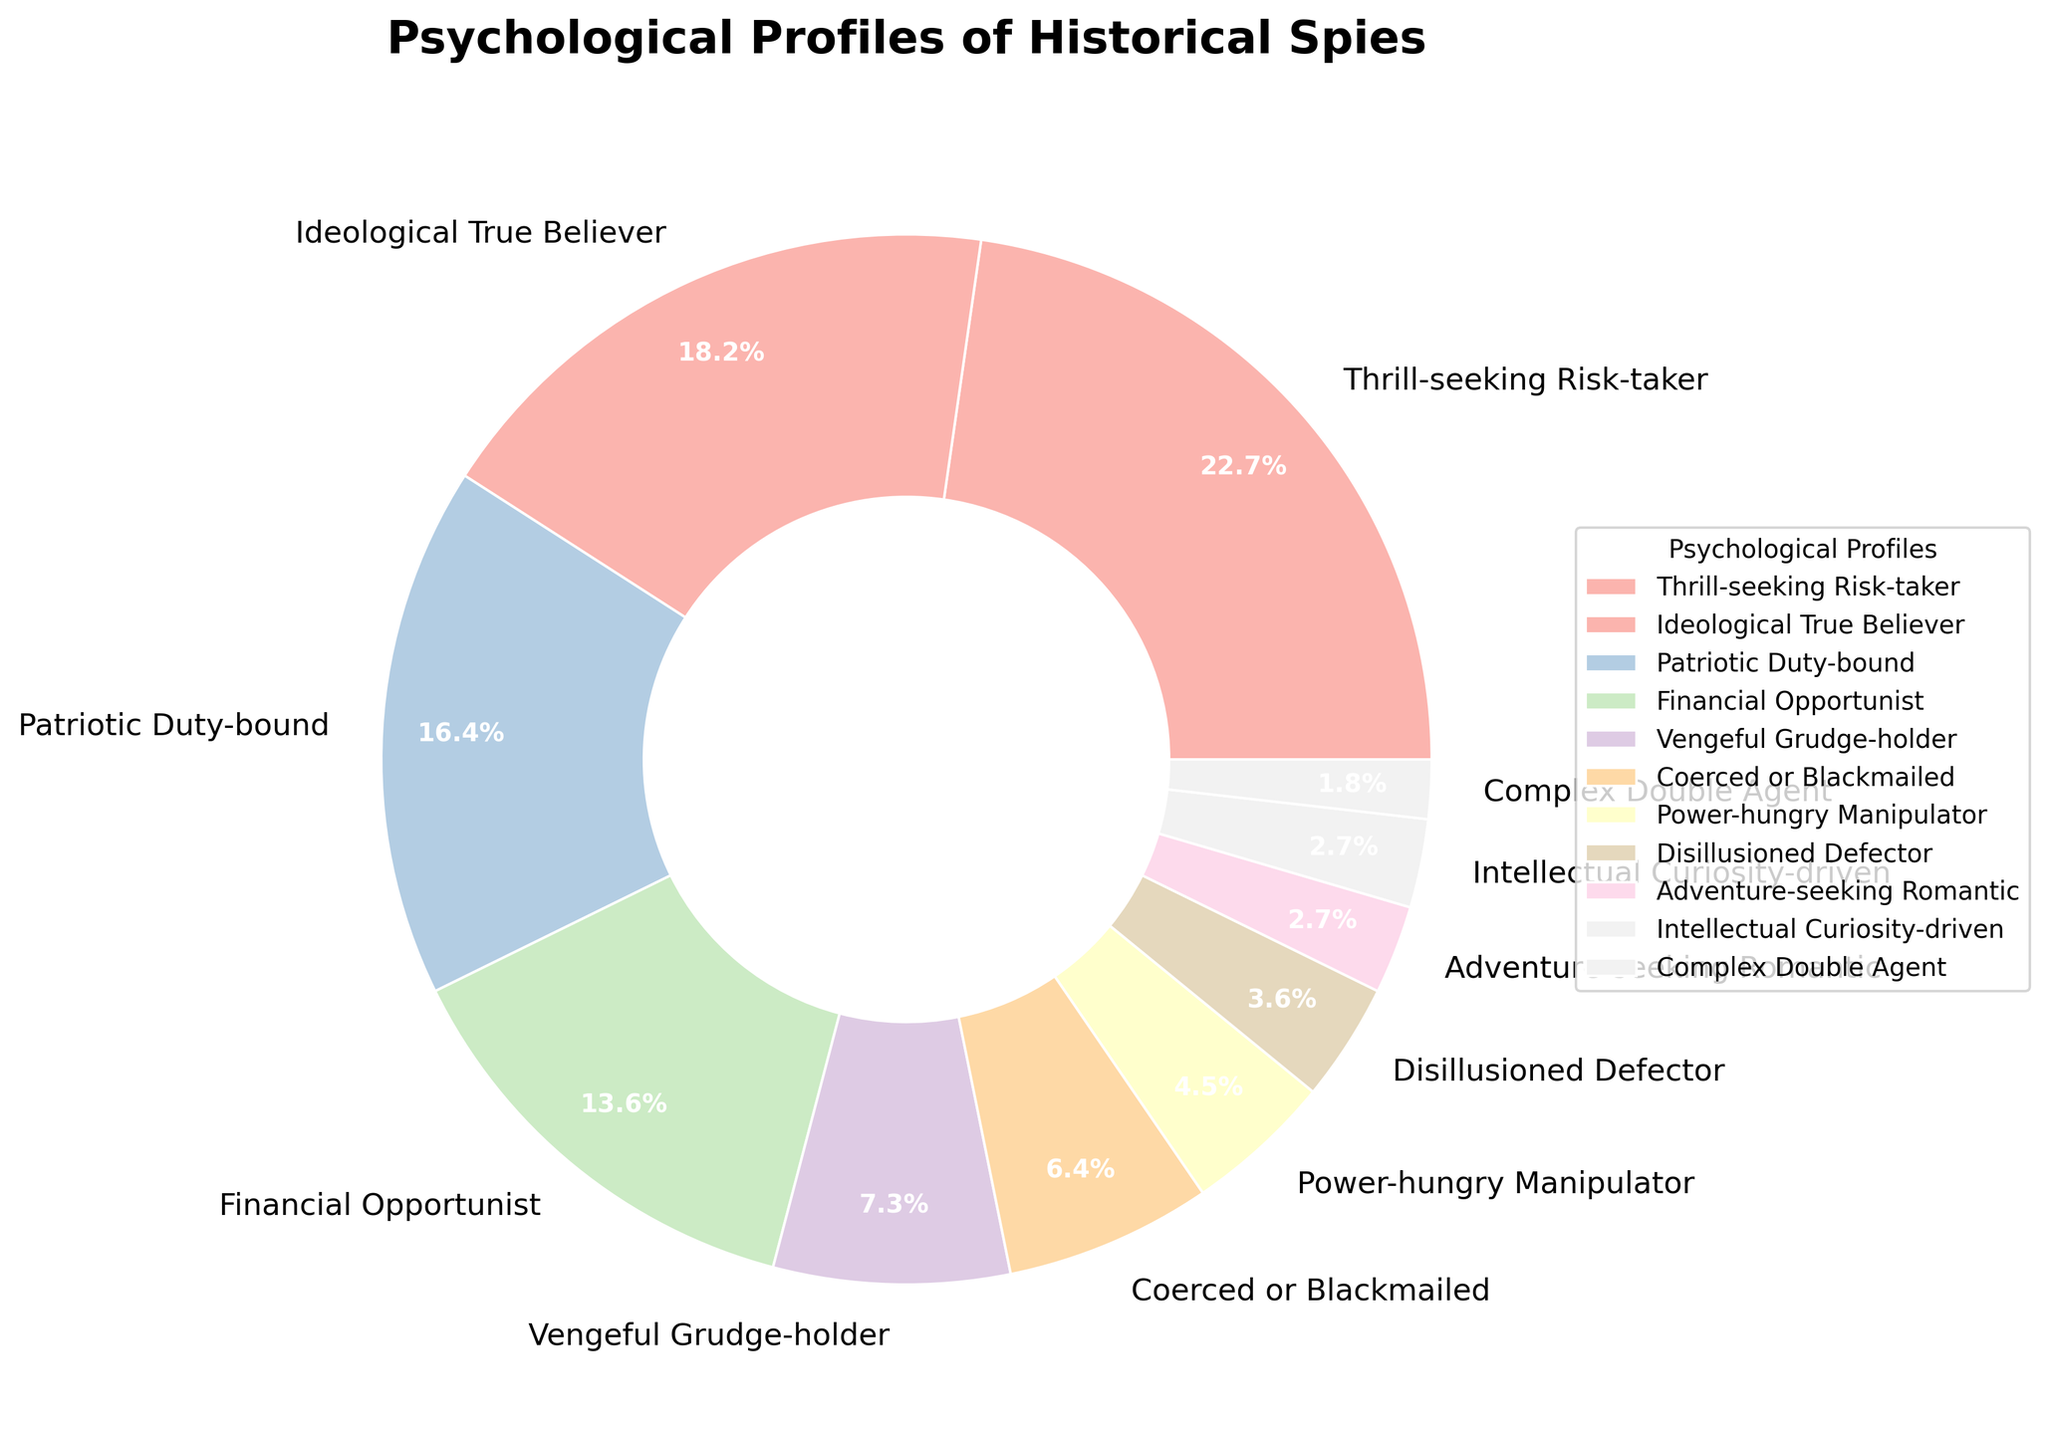Which psychological profile has the highest percentage among historical spies? Refer to the pie chart to identify the segment with the largest portion. The "Thrill-seeking Risk-taker" profile has the highest percentage at 25%.
Answer: Thrill-seeking Risk-taker What is the combined percentage of spies with profiles categorized as "Patriotic Duty-bound” and "Ideological True Believer"? Add the percentages of "Patriotic Duty-bound" (18%) and "Ideological True Believer" (20%). 18% + 20% = 38%.
Answer: 38% Which psychological profile has the smallest percentage representation in the chart? Observe the pie chart and identify the smallest segment. The "Complex Double Agent" profile is the smallest with 2%.
Answer: Complex Double Agent Are there more financial opportunist spies or vengeful grudge-holder spies? Compare the segments of "Financial Opportunist" (15%) and "Vengeful Grudge-holder" (8%). The "Financial Opportunist" profile is larger.
Answer: Financial Opportunist What is the total percentage of spies who have profiles driven by external forces (Coerced or Blackmailed and Power-hungry Manipulator)? Add the percentages of "Coerced or Blackmailed" (7%) and “Power-hungry Manipulator” (5%). 7% + 5% = 12%.
Answer: 12% Which profiles have equal representation in the chart? Observe the pie chart to identify profiles with the same percentage. "Adventure-seeking Romantic" and "Intellectual Curiosity-driven" both have 3%.
Answer: Adventure-seeking Romantic and Intellectual Curiosity-driven Which psychological profile category holds the third largest segment in the pie chart? Identify the third largest segment after "Thrill-seeking Risk-taker" (25%) and "Ideological True Believer" (20%). It is "Patriotic Duty-bound" with 18%.
Answer: Patriotic Duty-bound Do Adventure-seeking Romantic, Intellectual Curiosity-driven, and Complex Double Agent profiles combined contribute more than 10% of the total? Add the percentages of "Adventure-seeking Romantic" (3%), "Intellectual Curiosity-driven" (3%), and "Complex Double Agent" (2%). 3% + 3% + 2% = 8%, which is less than 10%.
Answer: No Which psychological profile segments fall between the 5% and 10% range? Identify profiles with percentages between 5% and 10%. The "Vengeful Grudge-holder" (8%) and “Coerced or Blackmailed” (7%) meet this criterion.
Answer: Vengeful Grudge-holder and Coerced or Blackmailed What is the difference in percentage between Power-hungry Manipulator and Complex Double Agent categories? Subtract the smaller percentage ("Complex Double Agent" at 2%) from the larger percentage ("Power-hungry Manipulator" at 5%). 5% - 2% = 3%.
Answer: 3% 